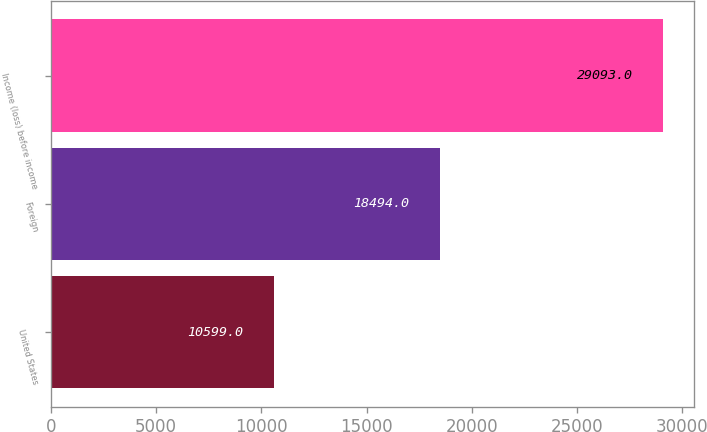Convert chart. <chart><loc_0><loc_0><loc_500><loc_500><bar_chart><fcel>United States<fcel>Foreign<fcel>Income (loss) before income<nl><fcel>10599<fcel>18494<fcel>29093<nl></chart> 